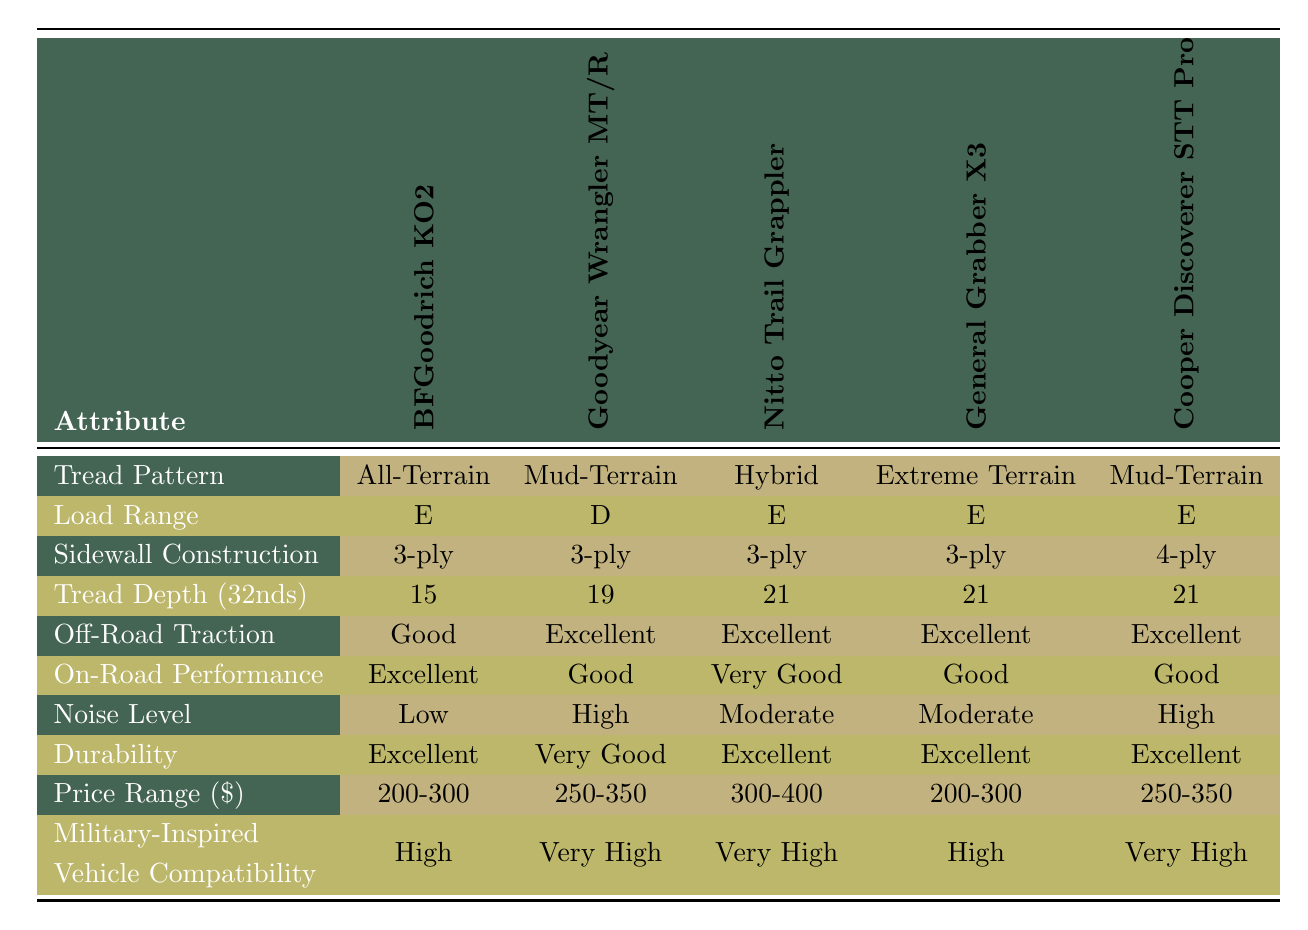What is the tread pattern of Nitto Trail Grappler? The tread pattern for the Nitto Trail Grappler is listed directly in the table under "Tread Pattern" in the corresponding column for this tire model, which states "Hybrid."
Answer: Hybrid How many tires have an off-road traction rating of "Excellent"? From the table, four tire models—Goodyear Wrangler MT/R, Nitto Trail Grappler, General Grabber X3, and Cooper Discoverer STT Pro—have "Excellent" off-road traction. Therefore, the count is 4.
Answer: 4 Is the sidewall construction for BFGoodrich KO2 a 4-ply? Looking at the table, the sidewall construction for BFGoodrich KO2 is identified as "3-ply." Thus, the statement is false.
Answer: No Which tire has the highest tread depth and what is its value? The Nitto Trail Grappler, General Grabber X3, and Cooper Discoverer STT Pro all show a tread depth of 21, which is the maximum value. Therefore, these three tires share the highest tread depth.
Answer: 21 Which tire is the least noisy based on the noise level ratings? By reviewing the noise level column, the BFGoodrich KO2 has a "Low" rating, while all other tires are either "Moderate" or "High," indicating it is the least noisy option.
Answer: BFGoodrich KO2 What is the average price range of these tire models? The price ranges are: 200-300 (1), 250-350 (3), and 300-400 (1). Converting these ranges into average values gives 250, 300, and 350. Calculating the overall average, we sum these and divide by 5: (250 + 250 + 300 + 350 + 300) / 5 = 290.
Answer: 290 What sidewall construction does the Goodyear Wrangler MT/R have? According to the table, the Goodyear Wrangler MT/R has a sidewall construction of "3-ply," directly listed under the relevant column in the table.
Answer: 3-ply Are all the tires compatible with military-inspired vehicles? The tires marked as compatible with military-inspired vehicles include: BFGoodrich KO2 (High), Goodyear Wrangler MT/R (Very High), Nitto Trail Grappler (Very High), General Grabber X3 (High), and Cooper Discoverer STT Pro (Very High). Since none are marked as incompatible, the answer is yes.
Answer: Yes 